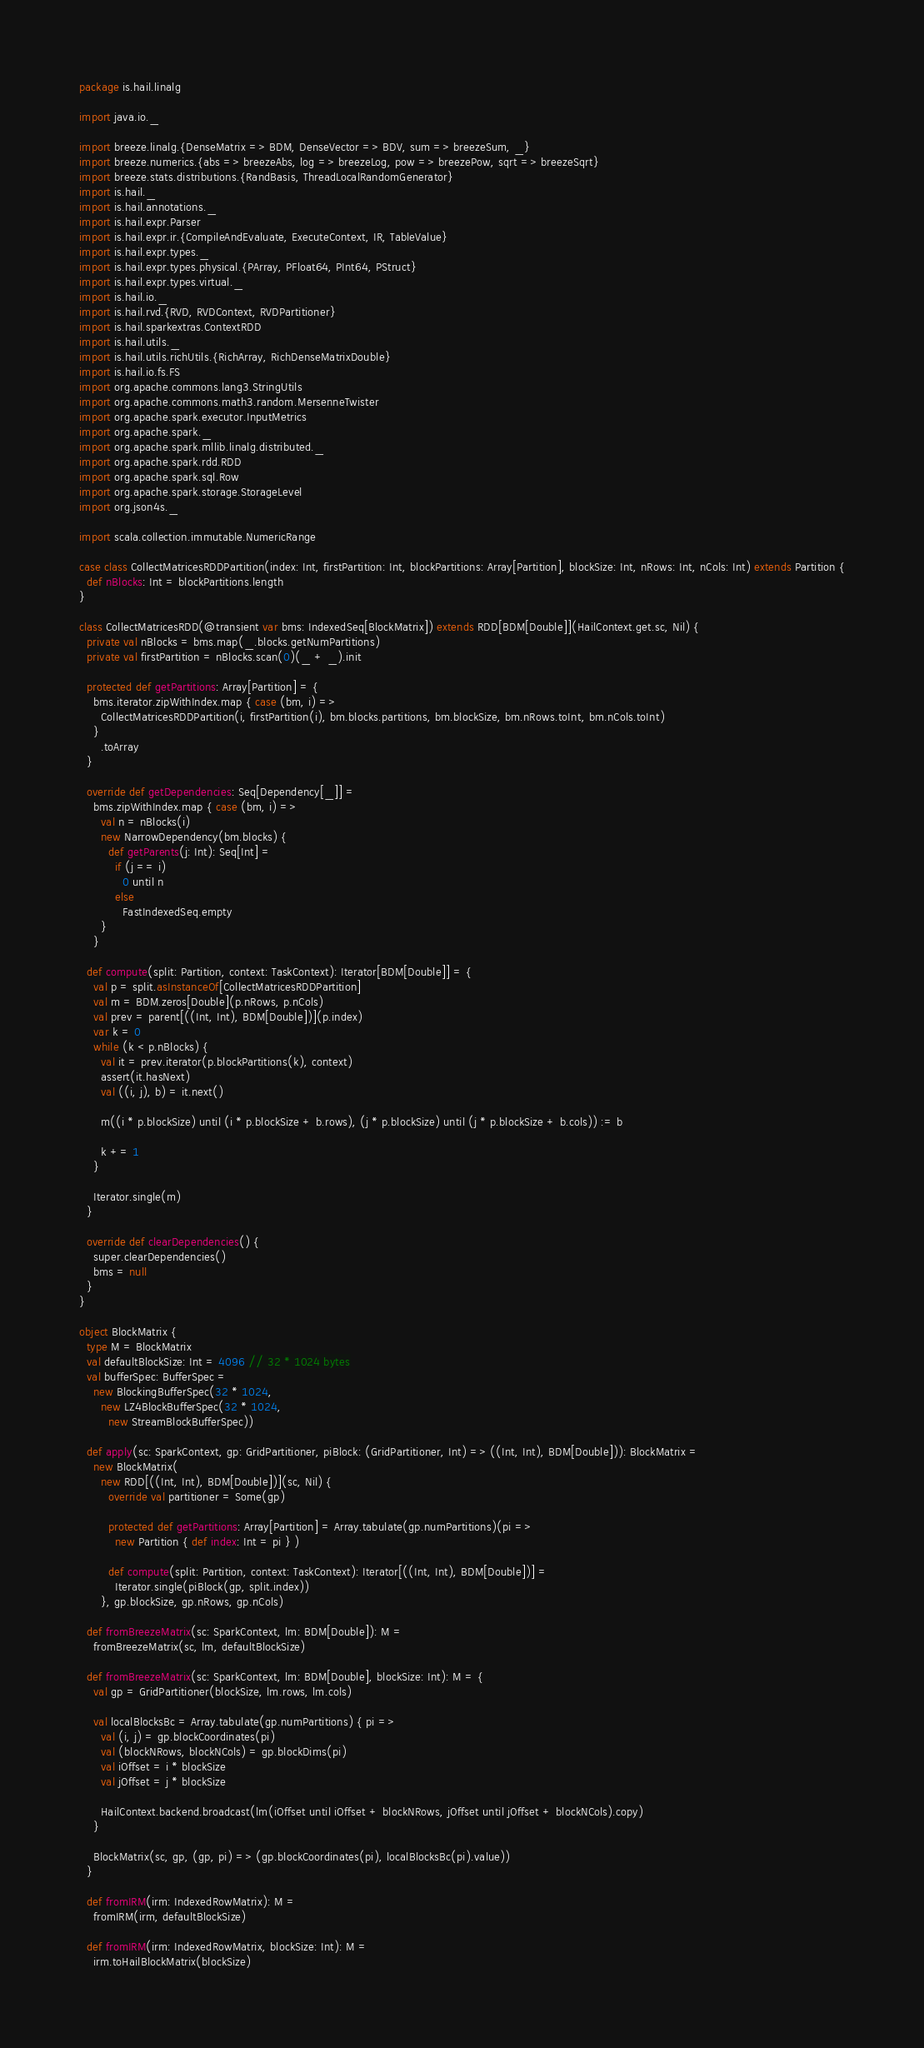<code> <loc_0><loc_0><loc_500><loc_500><_Scala_>package is.hail.linalg

import java.io._

import breeze.linalg.{DenseMatrix => BDM, DenseVector => BDV, sum => breezeSum, _}
import breeze.numerics.{abs => breezeAbs, log => breezeLog, pow => breezePow, sqrt => breezeSqrt}
import breeze.stats.distributions.{RandBasis, ThreadLocalRandomGenerator}
import is.hail._
import is.hail.annotations._
import is.hail.expr.Parser
import is.hail.expr.ir.{CompileAndEvaluate, ExecuteContext, IR, TableValue}
import is.hail.expr.types._
import is.hail.expr.types.physical.{PArray, PFloat64, PInt64, PStruct}
import is.hail.expr.types.virtual._
import is.hail.io._
import is.hail.rvd.{RVD, RVDContext, RVDPartitioner}
import is.hail.sparkextras.ContextRDD
import is.hail.utils._
import is.hail.utils.richUtils.{RichArray, RichDenseMatrixDouble}
import is.hail.io.fs.FS
import org.apache.commons.lang3.StringUtils
import org.apache.commons.math3.random.MersenneTwister
import org.apache.spark.executor.InputMetrics
import org.apache.spark._
import org.apache.spark.mllib.linalg.distributed._
import org.apache.spark.rdd.RDD
import org.apache.spark.sql.Row
import org.apache.spark.storage.StorageLevel
import org.json4s._

import scala.collection.immutable.NumericRange

case class CollectMatricesRDDPartition(index: Int, firstPartition: Int, blockPartitions: Array[Partition], blockSize: Int, nRows: Int, nCols: Int) extends Partition {
  def nBlocks: Int = blockPartitions.length
}

class CollectMatricesRDD(@transient var bms: IndexedSeq[BlockMatrix]) extends RDD[BDM[Double]](HailContext.get.sc, Nil) {
  private val nBlocks = bms.map(_.blocks.getNumPartitions)
  private val firstPartition = nBlocks.scan(0)(_ + _).init

  protected def getPartitions: Array[Partition] = {
    bms.iterator.zipWithIndex.map { case (bm, i) =>
      CollectMatricesRDDPartition(i, firstPartition(i), bm.blocks.partitions, bm.blockSize, bm.nRows.toInt, bm.nCols.toInt)
    }
      .toArray
  }

  override def getDependencies: Seq[Dependency[_]] =
    bms.zipWithIndex.map { case (bm, i) =>
      val n = nBlocks(i)
      new NarrowDependency(bm.blocks) {
        def getParents(j: Int): Seq[Int] =
          if (j == i)
            0 until n
          else
            FastIndexedSeq.empty
      }
    }

  def compute(split: Partition, context: TaskContext): Iterator[BDM[Double]] = {
    val p = split.asInstanceOf[CollectMatricesRDDPartition]
    val m = BDM.zeros[Double](p.nRows, p.nCols)
    val prev = parent[((Int, Int), BDM[Double])](p.index)
    var k = 0
    while (k < p.nBlocks) {
      val it = prev.iterator(p.blockPartitions(k), context)
      assert(it.hasNext)
      val ((i, j), b) = it.next()

      m((i * p.blockSize) until (i * p.blockSize + b.rows), (j * p.blockSize) until (j * p.blockSize + b.cols)) := b

      k += 1
    }

    Iterator.single(m)
  }

  override def clearDependencies() {
    super.clearDependencies()
    bms = null
  }
}

object BlockMatrix {
  type M = BlockMatrix
  val defaultBlockSize: Int = 4096 // 32 * 1024 bytes
  val bufferSpec: BufferSpec =
    new BlockingBufferSpec(32 * 1024,
      new LZ4BlockBufferSpec(32 * 1024,
        new StreamBlockBufferSpec))
  
  def apply(sc: SparkContext, gp: GridPartitioner, piBlock: (GridPartitioner, Int) => ((Int, Int), BDM[Double])): BlockMatrix =
    new BlockMatrix(
      new RDD[((Int, Int), BDM[Double])](sc, Nil) {
        override val partitioner = Some(gp)
  
        protected def getPartitions: Array[Partition] = Array.tabulate(gp.numPartitions)(pi =>
          new Partition { def index: Int = pi } )
  
        def compute(split: Partition, context: TaskContext): Iterator[((Int, Int), BDM[Double])] =
          Iterator.single(piBlock(gp, split.index))
      }, gp.blockSize, gp.nRows, gp.nCols)
  
  def fromBreezeMatrix(sc: SparkContext, lm: BDM[Double]): M =
    fromBreezeMatrix(sc, lm, defaultBlockSize)

  def fromBreezeMatrix(sc: SparkContext, lm: BDM[Double], blockSize: Int): M = {
    val gp = GridPartitioner(blockSize, lm.rows, lm.cols)
    
    val localBlocksBc = Array.tabulate(gp.numPartitions) { pi =>
      val (i, j) = gp.blockCoordinates(pi)
      val (blockNRows, blockNCols) = gp.blockDims(pi)
      val iOffset = i * blockSize
      val jOffset = j * blockSize

      HailContext.backend.broadcast(lm(iOffset until iOffset + blockNRows, jOffset until jOffset + blockNCols).copy)
    }
    
    BlockMatrix(sc, gp, (gp, pi) => (gp.blockCoordinates(pi), localBlocksBc(pi).value))
  }

  def fromIRM(irm: IndexedRowMatrix): M =
    fromIRM(irm, defaultBlockSize)

  def fromIRM(irm: IndexedRowMatrix, blockSize: Int): M =
    irm.toHailBlockMatrix(blockSize)
</code> 